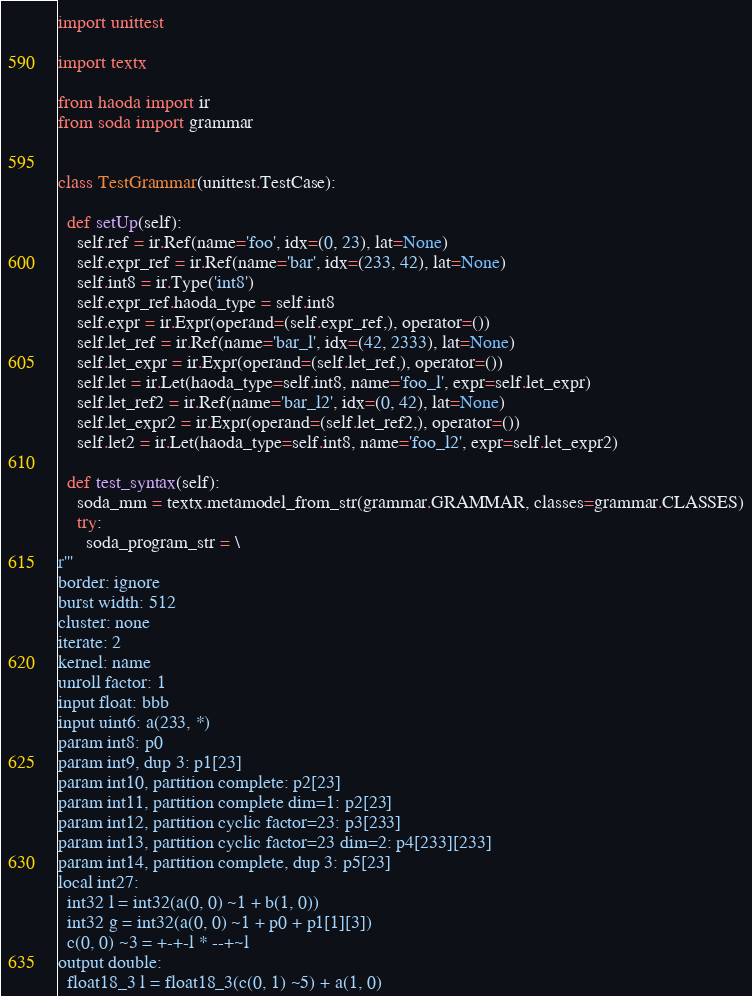<code> <loc_0><loc_0><loc_500><loc_500><_Python_>import unittest

import textx

from haoda import ir
from soda import grammar


class TestGrammar(unittest.TestCase):

  def setUp(self):
    self.ref = ir.Ref(name='foo', idx=(0, 23), lat=None)
    self.expr_ref = ir.Ref(name='bar', idx=(233, 42), lat=None)
    self.int8 = ir.Type('int8')
    self.expr_ref.haoda_type = self.int8
    self.expr = ir.Expr(operand=(self.expr_ref,), operator=())
    self.let_ref = ir.Ref(name='bar_l', idx=(42, 2333), lat=None)
    self.let_expr = ir.Expr(operand=(self.let_ref,), operator=())
    self.let = ir.Let(haoda_type=self.int8, name='foo_l', expr=self.let_expr)
    self.let_ref2 = ir.Ref(name='bar_l2', idx=(0, 42), lat=None)
    self.let_expr2 = ir.Expr(operand=(self.let_ref2,), operator=())
    self.let2 = ir.Let(haoda_type=self.int8, name='foo_l2', expr=self.let_expr2)

  def test_syntax(self):
    soda_mm = textx.metamodel_from_str(grammar.GRAMMAR, classes=grammar.CLASSES)
    try:
      soda_program_str = \
r'''
border: ignore
burst width: 512
cluster: none
iterate: 2
kernel: name
unroll factor: 1
input float: bbb
input uint6: a(233, *)
param int8: p0
param int9, dup 3: p1[23]
param int10, partition complete: p2[23]
param int11, partition complete dim=1: p2[23]
param int12, partition cyclic factor=23: p3[233]
param int13, partition cyclic factor=23 dim=2: p4[233][233]
param int14, partition complete, dup 3: p5[23]
local int27:
  int32 l = int32(a(0, 0) ~1 + b(1, 0))
  int32 g = int32(a(0, 0) ~1 + p0 + p1[1][3])
  c(0, 0) ~3 = +-+-l * --+~l
output double:
  float18_3 l = float18_3(c(0, 1) ~5) + a(1, 0)</code> 